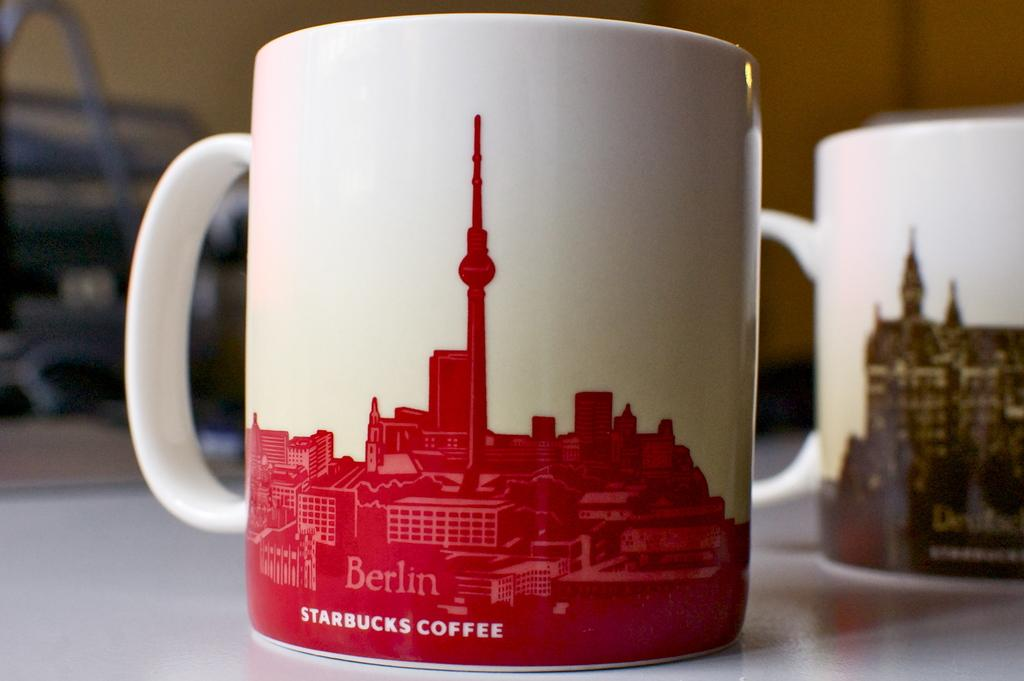What is the main object in the image? There is a table in the image. What is placed on the table? There are two coffee cups on the table. What can be seen on the coffee cups? The coffee cups have paintings of buildings on them and text. How would you describe the background of the image? The background of the image is blurred. Can you see a bee buzzing around the coffee cups in the image? There is no bee present in the image. What type of nose is depicted on the coffee cups? The coffee cups do not have any noses depicted on them. 